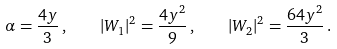Convert formula to latex. <formula><loc_0><loc_0><loc_500><loc_500>\alpha = \frac { 4 y } { 3 } \, , \quad | W _ { 1 } | ^ { 2 } = \frac { 4 y ^ { 2 } } { 9 } \, , \quad | W _ { 2 } | ^ { 2 } = \frac { 6 4 y ^ { 2 } } { 3 } \, .</formula> 